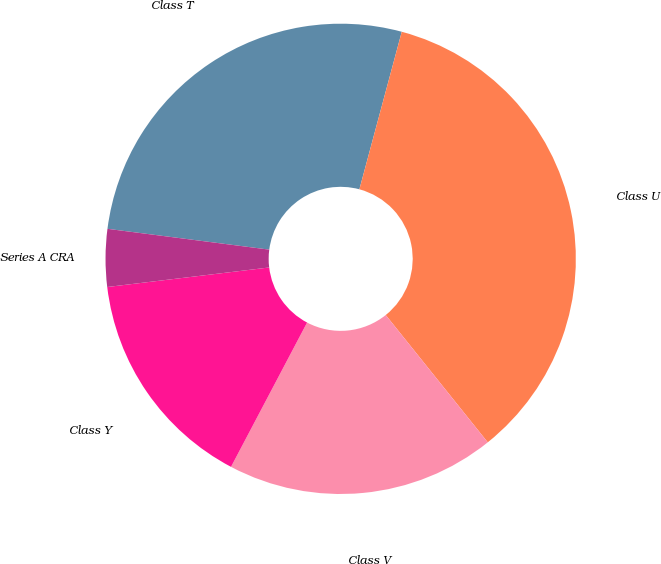Convert chart to OTSL. <chart><loc_0><loc_0><loc_500><loc_500><pie_chart><fcel>Class T<fcel>Class U<fcel>Class V<fcel>Class Y<fcel>Series A CRA<nl><fcel>27.15%<fcel>35.07%<fcel>18.48%<fcel>15.37%<fcel>3.95%<nl></chart> 